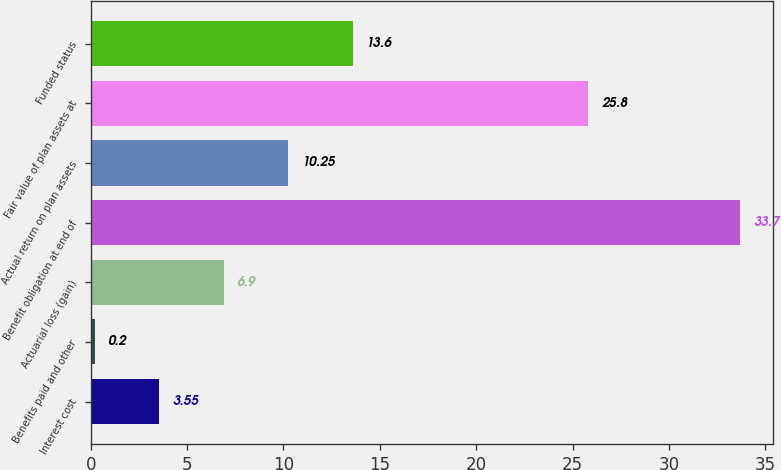<chart> <loc_0><loc_0><loc_500><loc_500><bar_chart><fcel>Interest cost<fcel>Benefits paid and other<fcel>Actuarial loss (gain)<fcel>Benefit obligation at end of<fcel>Actual return on plan assets<fcel>Fair value of plan assets at<fcel>Funded status<nl><fcel>3.55<fcel>0.2<fcel>6.9<fcel>33.7<fcel>10.25<fcel>25.8<fcel>13.6<nl></chart> 